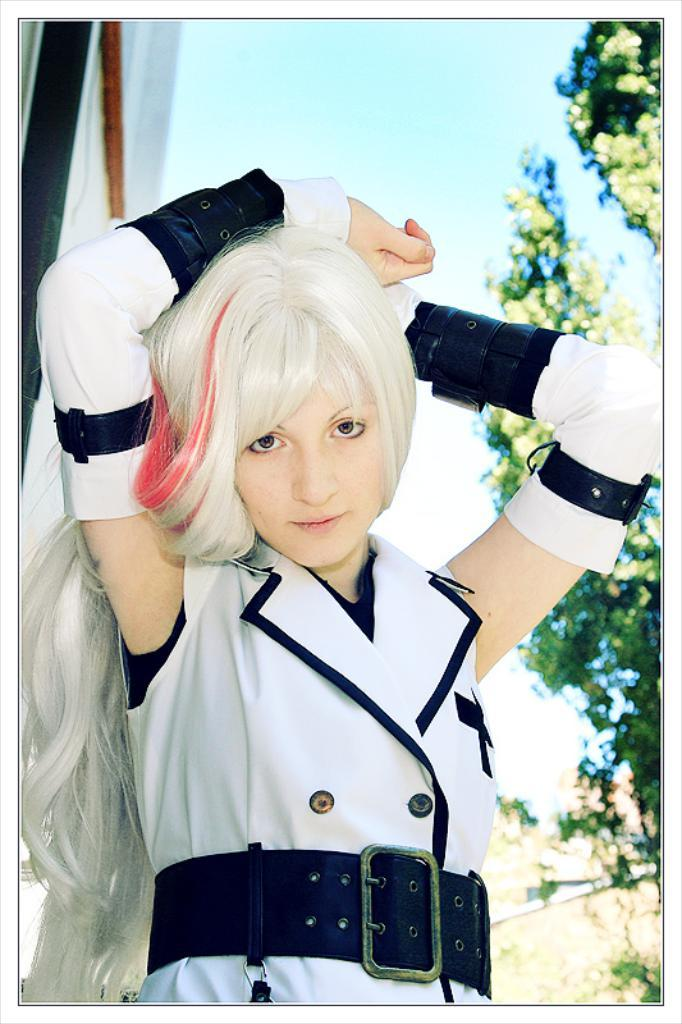What is the main subject of the image? There is a woman in the image. What is the woman wearing? The woman is wearing a white dress and a belt. What is the woman doing in the image? The woman is watching something. What can be seen in the background of the image? There is sky, a pole, cloth, and trees visible in the background of the image. What letter is the woman holding in the image? There is no letter present in the image. Is there a sink visible in the image? No, there is no sink present in the image. 